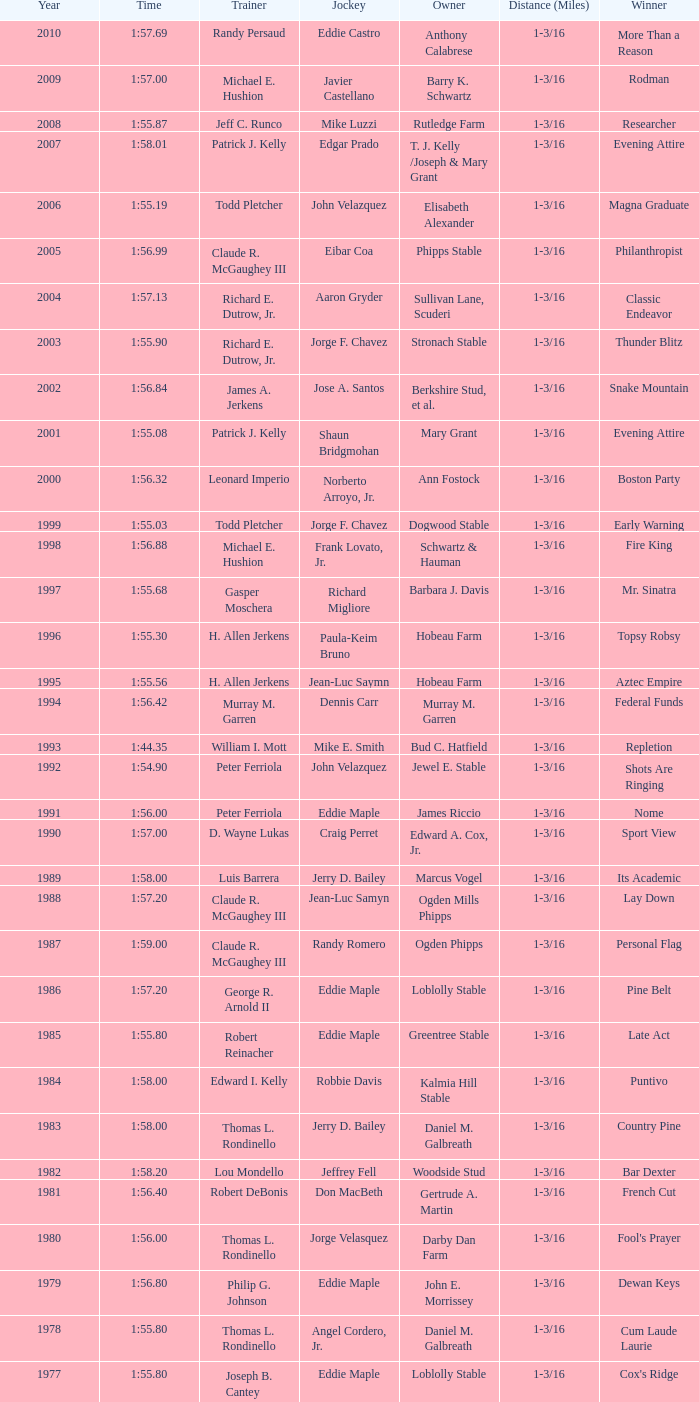Who was the jockey for the winning horse Helioptic? Paul Miller. 